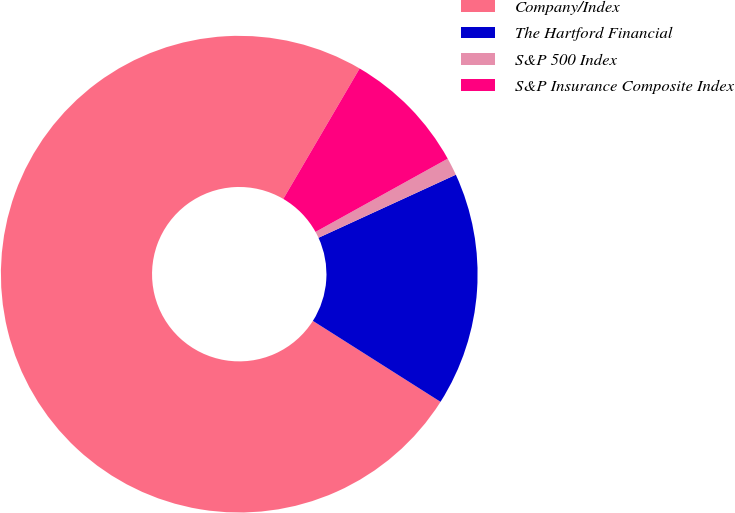Convert chart. <chart><loc_0><loc_0><loc_500><loc_500><pie_chart><fcel>Company/Index<fcel>The Hartford Financial<fcel>S&P 500 Index<fcel>S&P Insurance Composite Index<nl><fcel>74.44%<fcel>15.85%<fcel>1.2%<fcel>8.52%<nl></chart> 